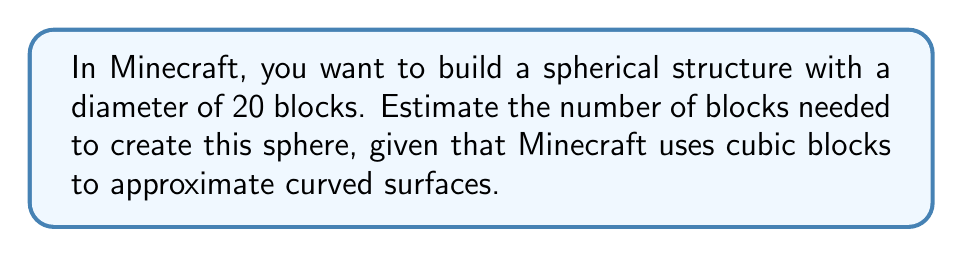Provide a solution to this math problem. To estimate the number of blocks needed for a spherical structure in Minecraft, we'll use the volume of a sphere and compare it to the volume of a cube. Here's the step-by-step process:

1. Calculate the volume of the sphere:
   The volume of a sphere is given by the formula $V_s = \frac{4}{3}\pi r^3$
   Where $r$ is the radius, which is half the diameter.
   $r = 20/2 = 10$ blocks
   $$V_s = \frac{4}{3}\pi (10)^3 \approx 4188.79 \text{ cubic blocks}$$

2. Round up to the nearest whole number:
   $V_s \approx 4189 \text{ blocks}$

3. Consider that Minecraft uses cubic blocks to approximate curved surfaces:
   This means we need to account for some extra blocks to create a more spherical appearance. A common estimation is to add about 5-10% more blocks.

4. Calculate the final estimate:
   Let's add 7% to our rounded volume:
   $$4189 \times 1.07 \approx 4482.23 \text{ blocks}$$

5. Round up to the nearest whole number for our final estimate:
   $4483 \text{ blocks}$

This estimation provides a good starting point for building a spherical structure in Minecraft, accounting for the cubic nature of the blocks and the need for a more rounded appearance.
Answer: Approximately 4483 blocks 